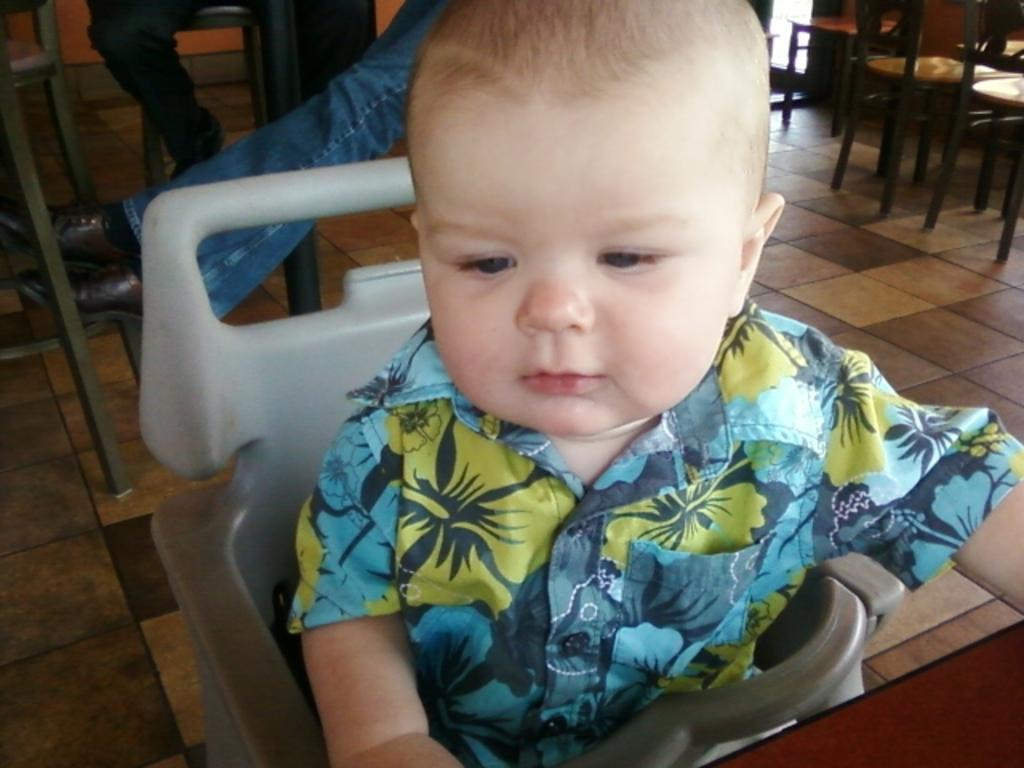What type of furniture is present in the image? There are chairs in the image. Can you describe the position of the child in the image? A child is sitting on a chair in the front of the image. What theory is the child discussing while sitting on the chair in the image? There is no indication in the image that the child is discussing any theory. 